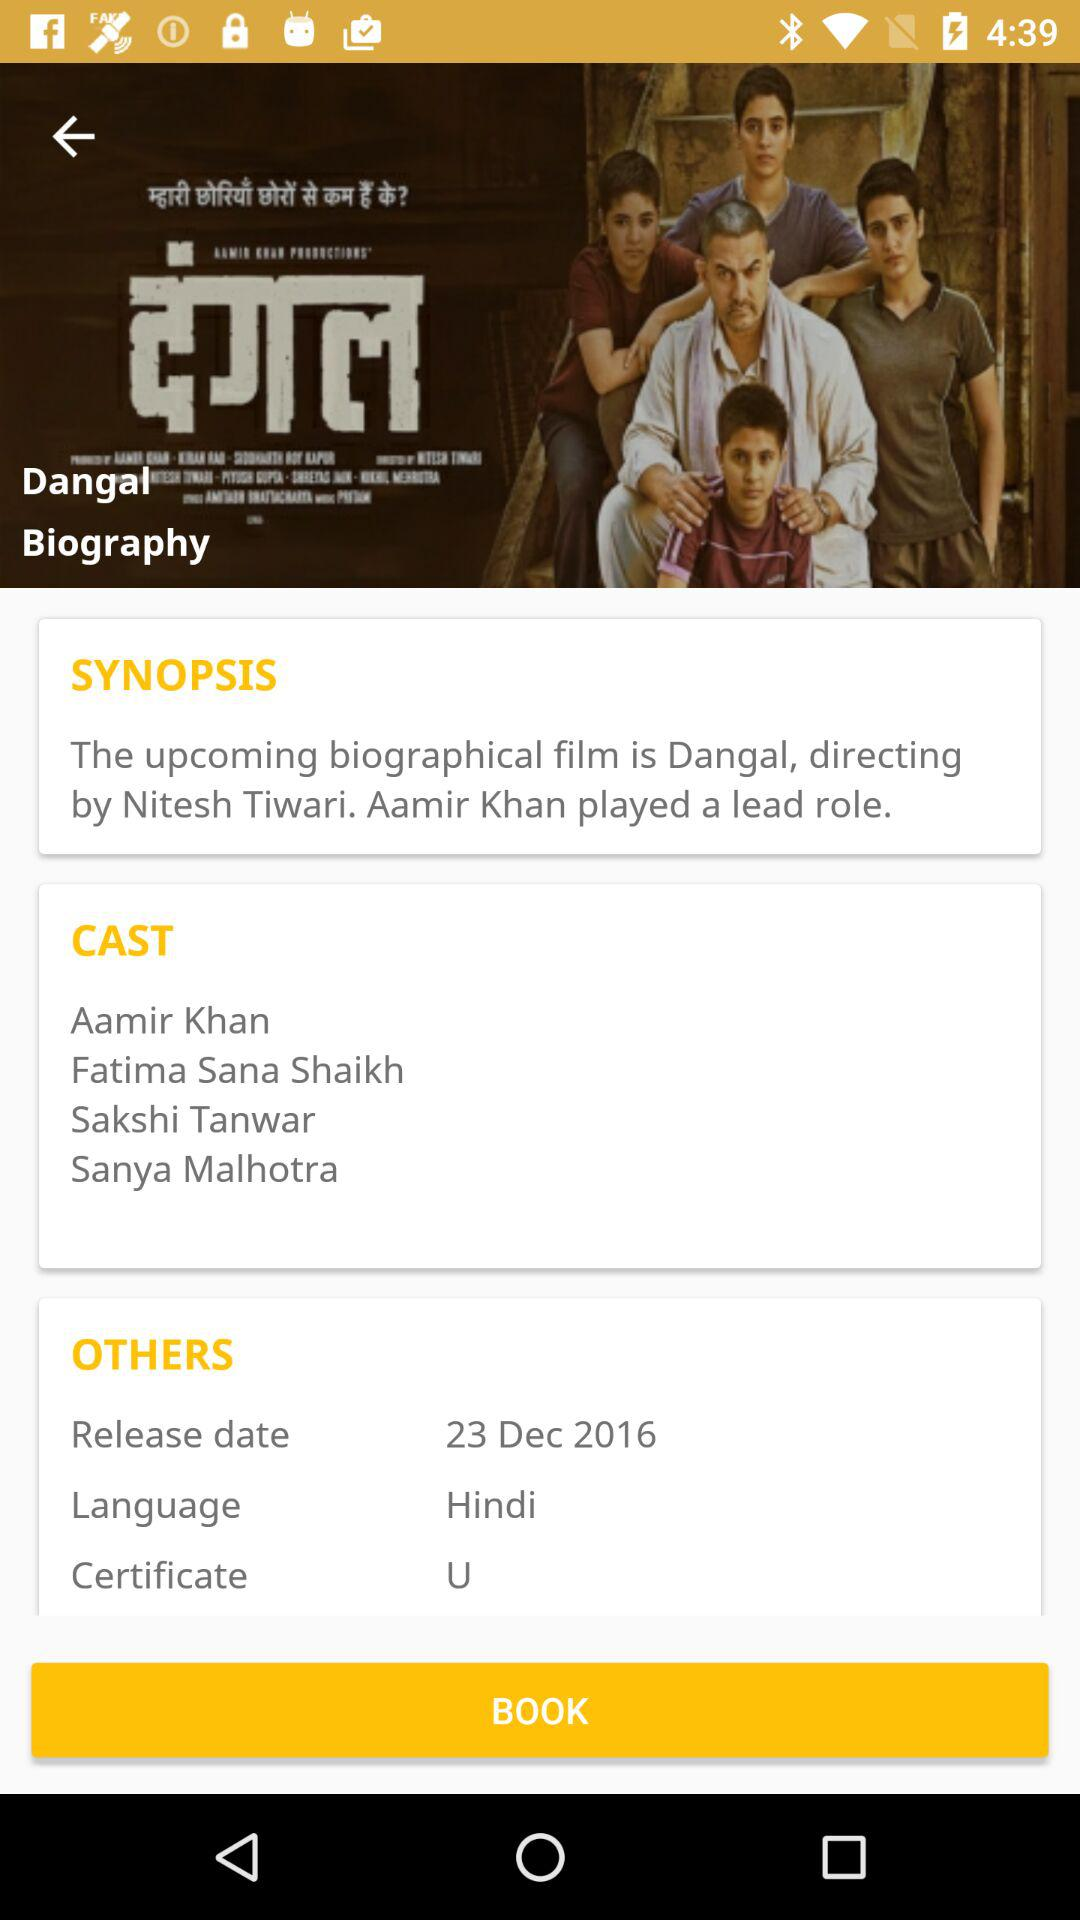What is the genre of the movie? The genre of the movie is biography. 